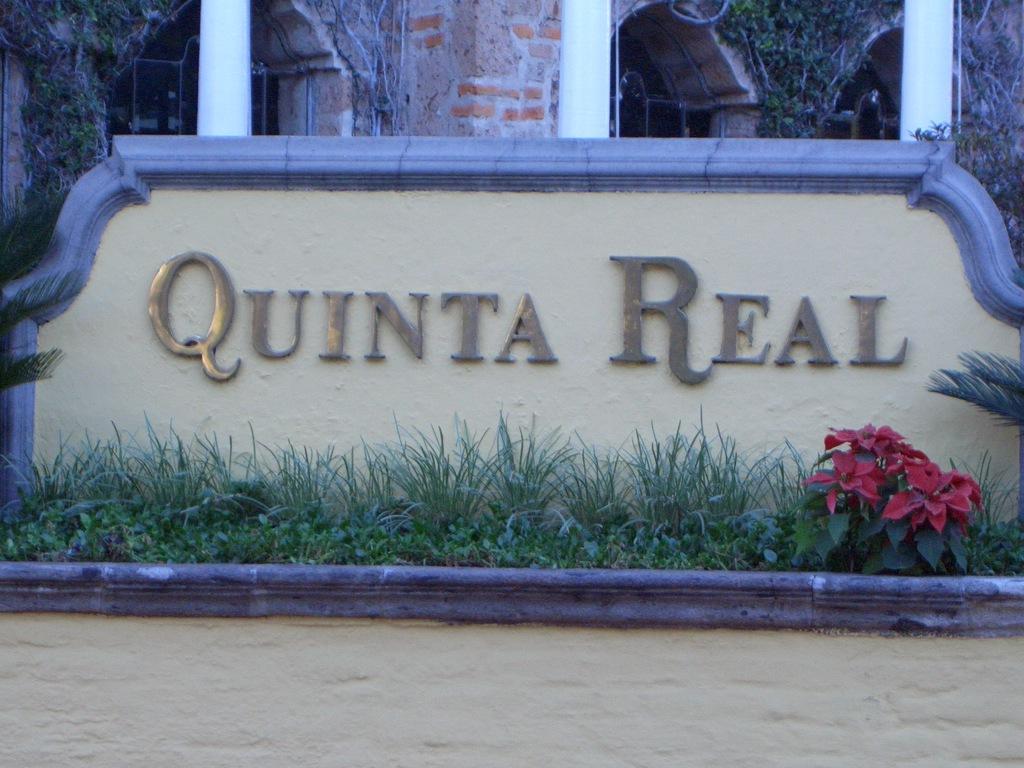Could you give a brief overview of what you see in this image? In this image I can see the wall and the name quinta real is written on the wall. In-front of the wall I can see the grass and the plant. There are the red color flowers to the plant. In the background I can see the pillars and the building. 